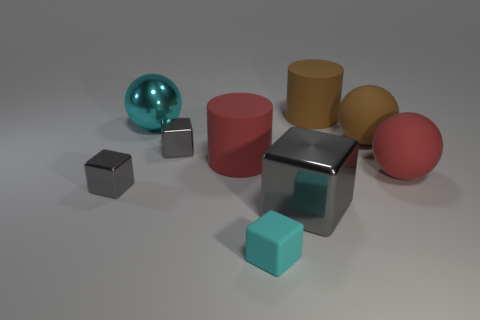How many gray blocks must be subtracted to get 1 gray blocks? 2 Subtract all large rubber spheres. How many spheres are left? 1 Add 1 cyan things. How many objects exist? 10 Subtract all purple cylinders. How many gray blocks are left? 3 Subtract all brown cylinders. How many cylinders are left? 1 Subtract 2 cylinders. How many cylinders are left? 0 Add 2 yellow matte objects. How many yellow matte objects exist? 2 Subtract 0 gray cylinders. How many objects are left? 9 Subtract all cylinders. How many objects are left? 7 Subtract all blue balls. Subtract all red cylinders. How many balls are left? 3 